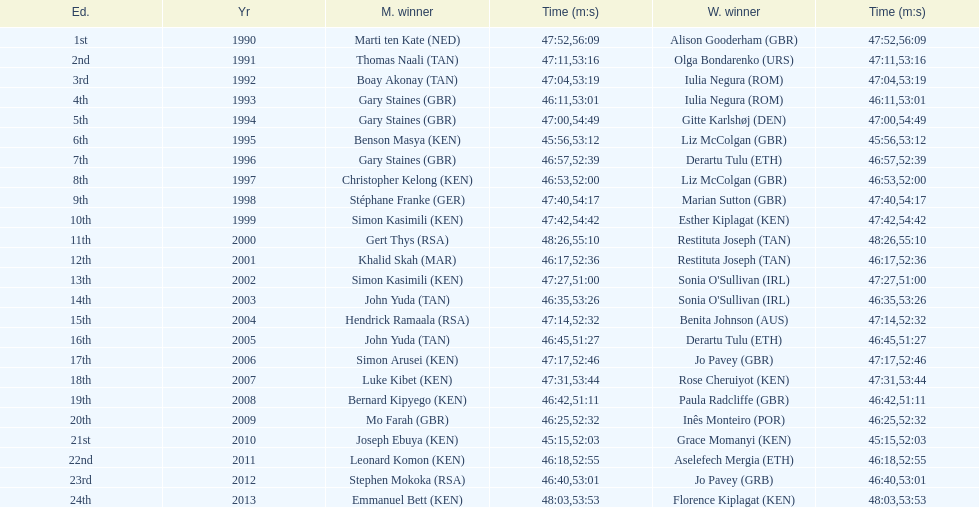Can we find examples of women being faster than men? No. 